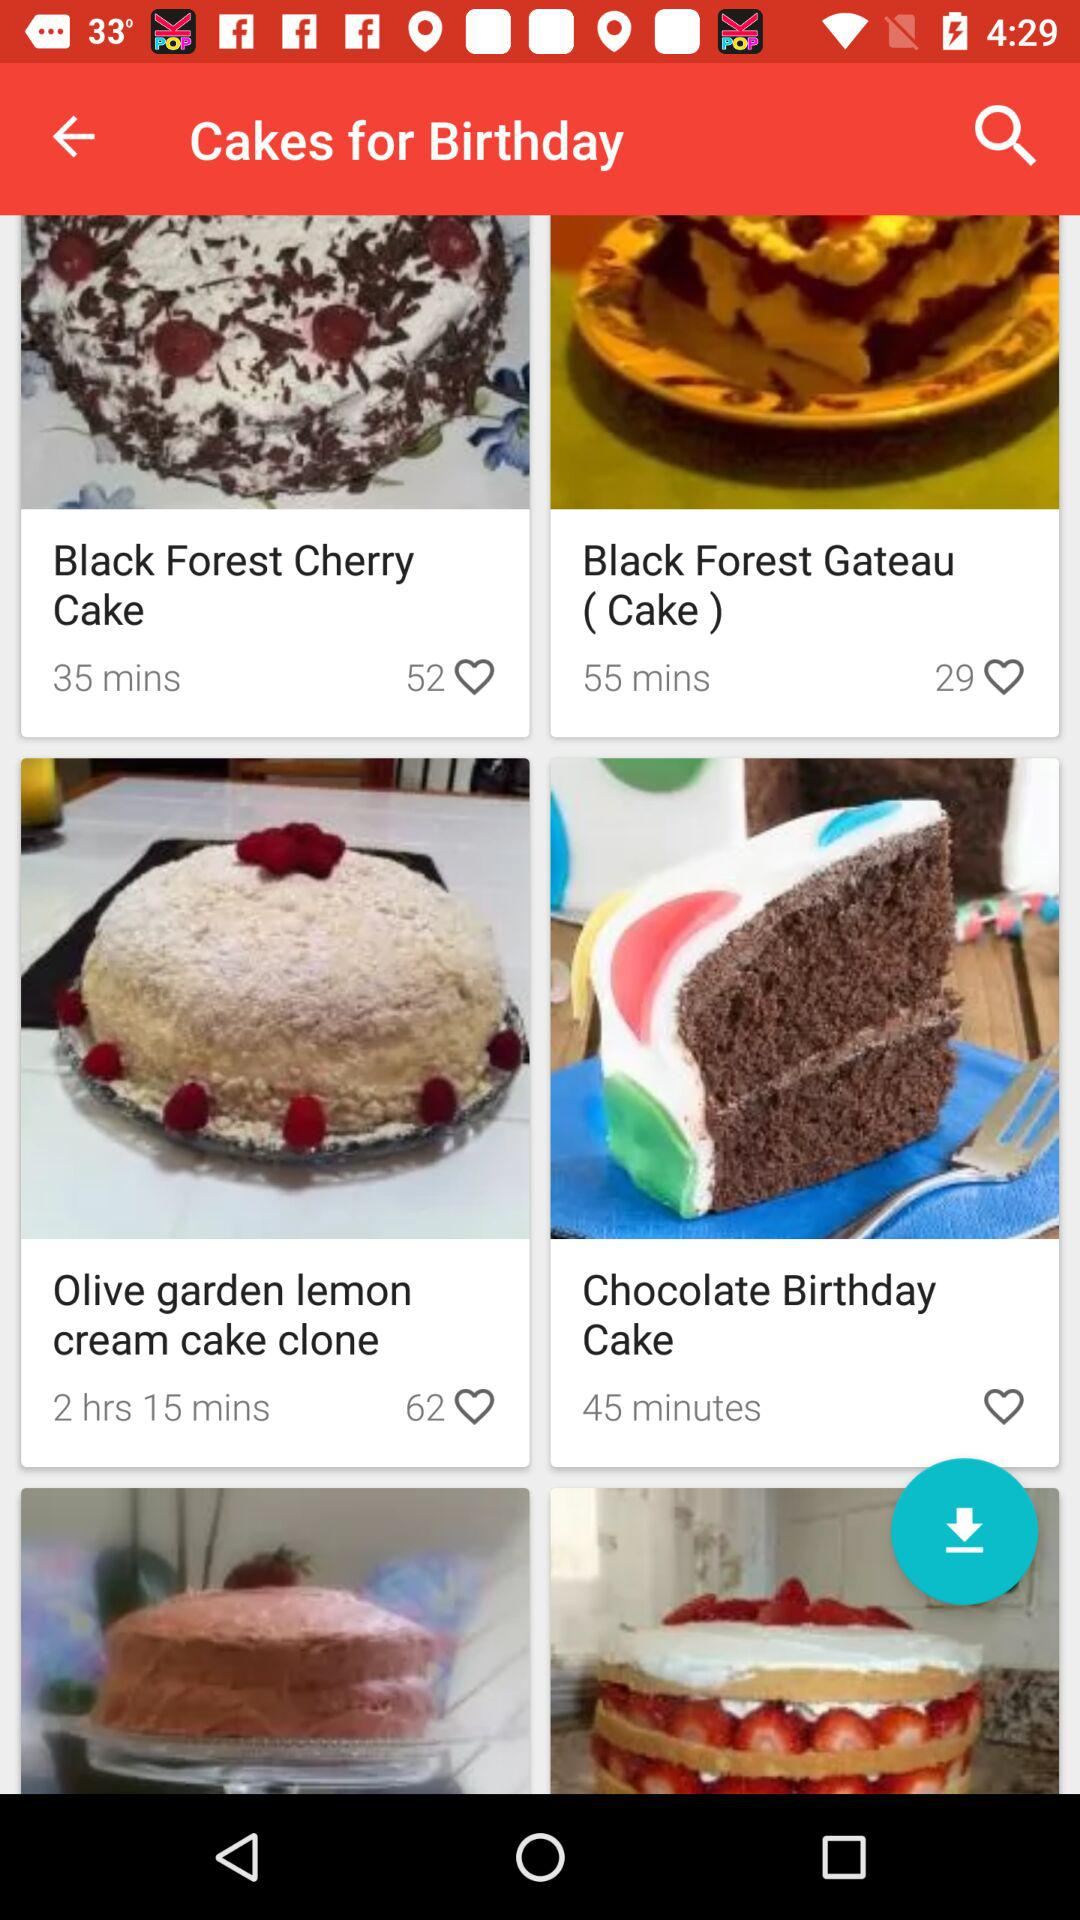How many people have liked Black Forest Gateau Cake? There are 29 people. 